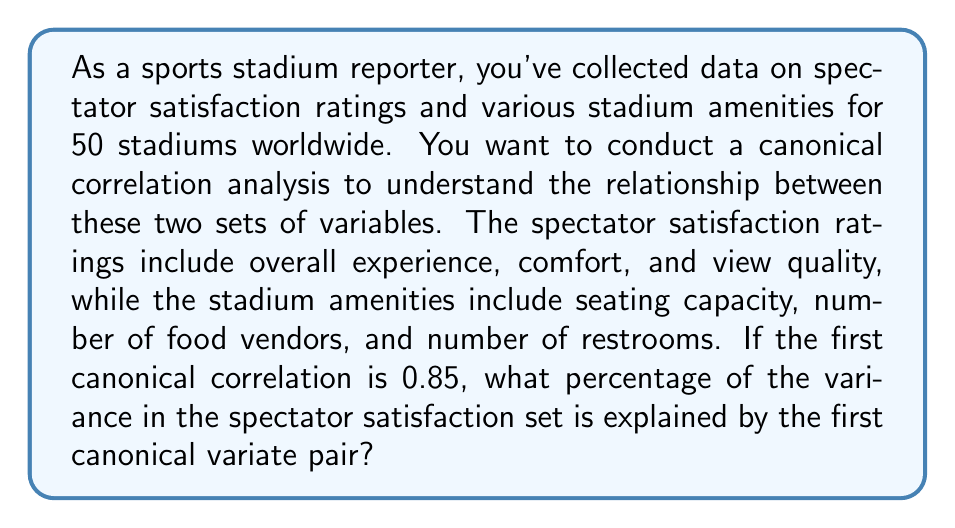Teach me how to tackle this problem. To solve this problem, we need to understand the concept of canonical correlation analysis and how to interpret its results. Let's break it down step-by-step:

1) Canonical correlation analysis (CCA) is a method used to identify and measure the associations between two sets of variables. In this case, we have:
   Set 1 (X): Spectator satisfaction ratings (overall experience, comfort, view quality)
   Set 2 (Y): Stadium amenities (seating capacity, number of food vendors, number of restrooms)

2) The analysis produces canonical variates, which are linear combinations of the original variables in each set. These variates are created to maximize the correlation between the two sets.

3) The correlation between the first pair of canonical variates is called the first canonical correlation, which in this case is given as 0.85.

4) To find the percentage of variance explained by the first canonical variate pair, we need to square the canonical correlation. This is because the square of the correlation coefficient represents the proportion of variance shared between two variables.

5) Let's call the first canonical correlation $r_c$. The proportion of variance explained is $r_c^2$.

6) Calculate:
   $r_c^2 = (0.85)^2 = 0.7225$

7) To express this as a percentage, multiply by 100:
   $0.7225 * 100 = 72.25\%$

Therefore, the first canonical variate pair explains 72.25% of the variance in the spectator satisfaction set.
Answer: 72.25% 